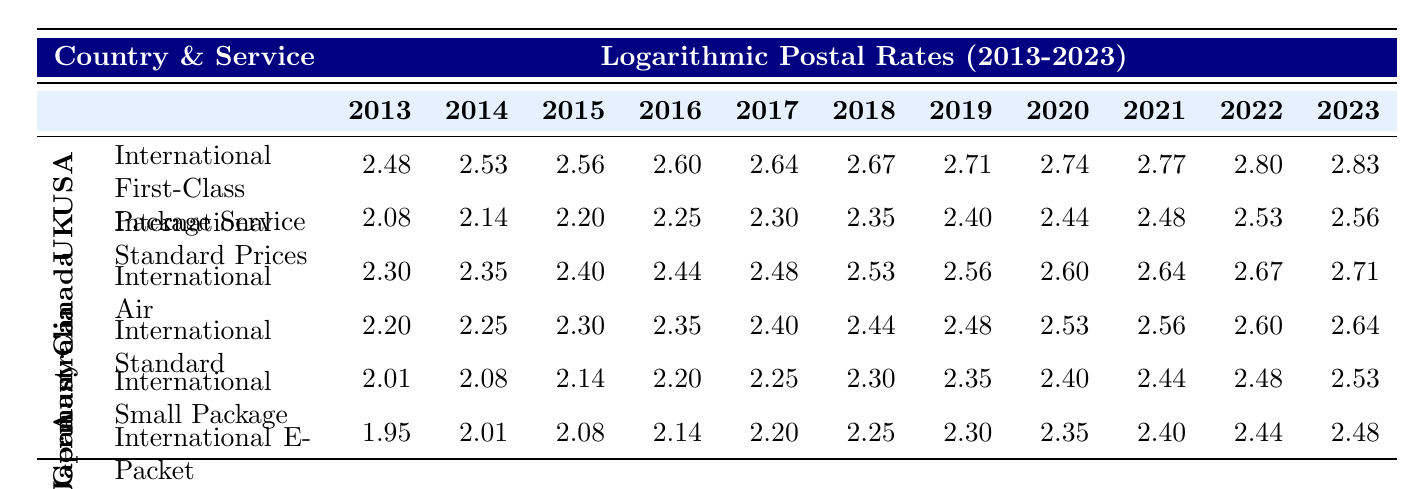What was the postal rate from Japan for the year 2020? Referring to the row for Japan and the column for the year 2020, the rate listed is 10.50.
Answer: 10.50 What was the increase in postal rates for the United States from 2013 to 2023? The rate for the United States in 2013 is 12.00, and in 2023 it is 17.00. The difference is 17.00 - 12.00 = 5.00.
Answer: 5.00 Was the postal rate for Canada in 2017 higher than 12.00? The rate for Canada in 2017 is 12.00, so it is not higher than 12.00.
Answer: No What is the average postal rate in 2022 across all countries listed? The rates for 2022 are: USA 16.50, UK 12.50, Canada 14.50, Australia 13.50, Germany 12.00, Japan 11.50. Summing them yields 16.50 + 12.50 + 14.50 + 13.50 + 12.00 + 11.50 = 80.00. Dividing by 6 gives an average of 80.00 / 6 = 13.33.
Answer: 13.33 How do the postal rates from Germany in 2015 and Japan in 2015 compare? The postal rate for Germany in 2015 is 8.50, while for Japan it is 8.00. Since 8.50 is greater than 8.00, Germany's rate is higher.
Answer: Germany's rate is higher What is the percentage increase in postal rates for Australia from 2013 to 2023? The rate for Australia in 2013 is 9.00 and in 2023 it is 14.00. The increase is 14.00 - 9.00 = 5.00. The percentage increase is (5.00 / 9.00) * 100 ≈ 55.56%.
Answer: Approximately 55.56% Which country had the lowest postal rate in 2013? The rates for 2013 are: USA 12.00, UK 8.00, Canada 10.00, Australia 9.00, Germany 7.50, Japan 7.00. The lowest rate is 7.00 from Japan.
Answer: Japan Were the postal rates for Australia and Canada the same in 2020? The rate for Australia in 2020 is 12.50 and for Canada it is 13.50. Since the two values are not equal, the rates were not the same.
Answer: No What was the trend in postal rates for the UK from 2013 to 2023? Referring to the UK row, the rates show a consistent increase from 8.00 in 2013 to 13.00 in 2023, indicating an upward trend.
Answer: Upward trend 